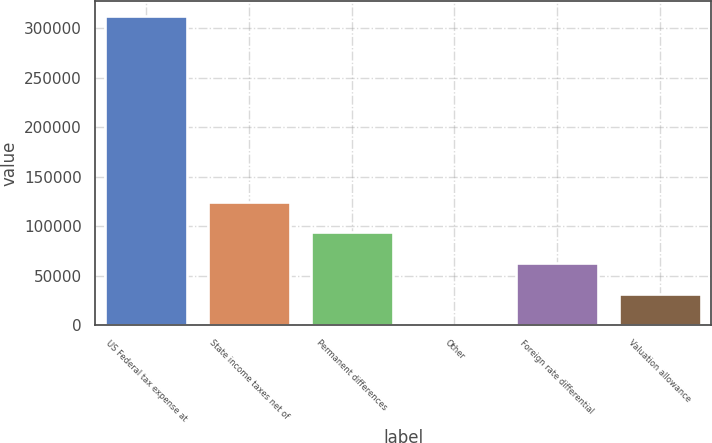Convert chart to OTSL. <chart><loc_0><loc_0><loc_500><loc_500><bar_chart><fcel>US Federal tax expense at<fcel>State income taxes net of<fcel>Permanent differences<fcel>Other<fcel>Foreign rate differential<fcel>Valuation allowance<nl><fcel>312042<fcel>124893<fcel>93701.5<fcel>127<fcel>62510<fcel>31318.5<nl></chart> 